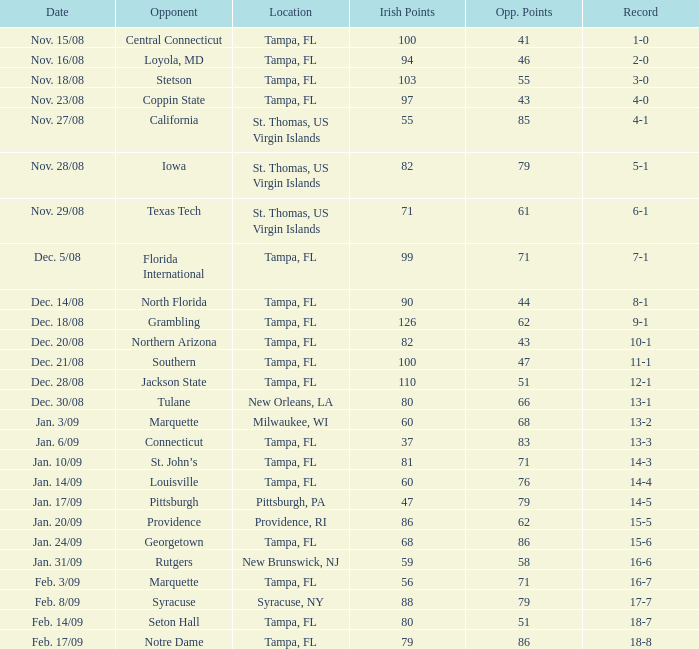What is the performance record when facing central connecticut as an opponent? 1-0. 